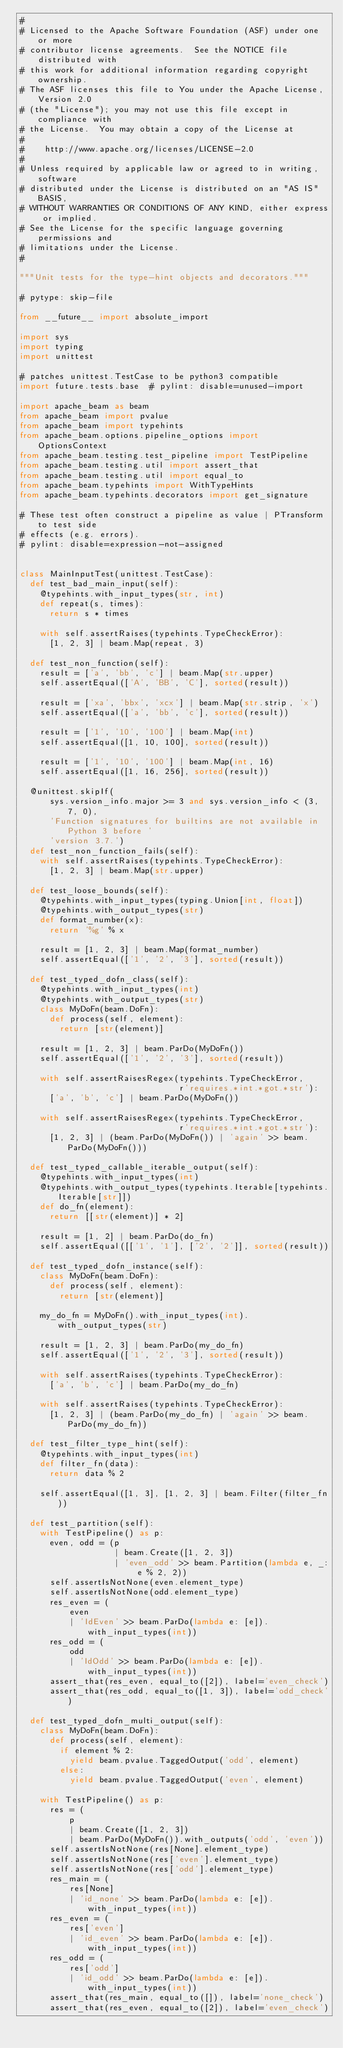Convert code to text. <code><loc_0><loc_0><loc_500><loc_500><_Python_>#
# Licensed to the Apache Software Foundation (ASF) under one or more
# contributor license agreements.  See the NOTICE file distributed with
# this work for additional information regarding copyright ownership.
# The ASF licenses this file to You under the Apache License, Version 2.0
# (the "License"); you may not use this file except in compliance with
# the License.  You may obtain a copy of the License at
#
#    http://www.apache.org/licenses/LICENSE-2.0
#
# Unless required by applicable law or agreed to in writing, software
# distributed under the License is distributed on an "AS IS" BASIS,
# WITHOUT WARRANTIES OR CONDITIONS OF ANY KIND, either express or implied.
# See the License for the specific language governing permissions and
# limitations under the License.
#

"""Unit tests for the type-hint objects and decorators."""

# pytype: skip-file

from __future__ import absolute_import

import sys
import typing
import unittest

# patches unittest.TestCase to be python3 compatible
import future.tests.base  # pylint: disable=unused-import

import apache_beam as beam
from apache_beam import pvalue
from apache_beam import typehints
from apache_beam.options.pipeline_options import OptionsContext
from apache_beam.testing.test_pipeline import TestPipeline
from apache_beam.testing.util import assert_that
from apache_beam.testing.util import equal_to
from apache_beam.typehints import WithTypeHints
from apache_beam.typehints.decorators import get_signature

# These test often construct a pipeline as value | PTransform to test side
# effects (e.g. errors).
# pylint: disable=expression-not-assigned


class MainInputTest(unittest.TestCase):
  def test_bad_main_input(self):
    @typehints.with_input_types(str, int)
    def repeat(s, times):
      return s * times

    with self.assertRaises(typehints.TypeCheckError):
      [1, 2, 3] | beam.Map(repeat, 3)

  def test_non_function(self):
    result = ['a', 'bb', 'c'] | beam.Map(str.upper)
    self.assertEqual(['A', 'BB', 'C'], sorted(result))

    result = ['xa', 'bbx', 'xcx'] | beam.Map(str.strip, 'x')
    self.assertEqual(['a', 'bb', 'c'], sorted(result))

    result = ['1', '10', '100'] | beam.Map(int)
    self.assertEqual([1, 10, 100], sorted(result))

    result = ['1', '10', '100'] | beam.Map(int, 16)
    self.assertEqual([1, 16, 256], sorted(result))

  @unittest.skipIf(
      sys.version_info.major >= 3 and sys.version_info < (3, 7, 0),
      'Function signatures for builtins are not available in Python 3 before '
      'version 3.7.')
  def test_non_function_fails(self):
    with self.assertRaises(typehints.TypeCheckError):
      [1, 2, 3] | beam.Map(str.upper)

  def test_loose_bounds(self):
    @typehints.with_input_types(typing.Union[int, float])
    @typehints.with_output_types(str)
    def format_number(x):
      return '%g' % x

    result = [1, 2, 3] | beam.Map(format_number)
    self.assertEqual(['1', '2', '3'], sorted(result))

  def test_typed_dofn_class(self):
    @typehints.with_input_types(int)
    @typehints.with_output_types(str)
    class MyDoFn(beam.DoFn):
      def process(self, element):
        return [str(element)]

    result = [1, 2, 3] | beam.ParDo(MyDoFn())
    self.assertEqual(['1', '2', '3'], sorted(result))

    with self.assertRaisesRegex(typehints.TypeCheckError,
                                r'requires.*int.*got.*str'):
      ['a', 'b', 'c'] | beam.ParDo(MyDoFn())

    with self.assertRaisesRegex(typehints.TypeCheckError,
                                r'requires.*int.*got.*str'):
      [1, 2, 3] | (beam.ParDo(MyDoFn()) | 'again' >> beam.ParDo(MyDoFn()))

  def test_typed_callable_iterable_output(self):
    @typehints.with_input_types(int)
    @typehints.with_output_types(typehints.Iterable[typehints.Iterable[str]])
    def do_fn(element):
      return [[str(element)] * 2]

    result = [1, 2] | beam.ParDo(do_fn)
    self.assertEqual([['1', '1'], ['2', '2']], sorted(result))

  def test_typed_dofn_instance(self):
    class MyDoFn(beam.DoFn):
      def process(self, element):
        return [str(element)]

    my_do_fn = MyDoFn().with_input_types(int).with_output_types(str)

    result = [1, 2, 3] | beam.ParDo(my_do_fn)
    self.assertEqual(['1', '2', '3'], sorted(result))

    with self.assertRaises(typehints.TypeCheckError):
      ['a', 'b', 'c'] | beam.ParDo(my_do_fn)

    with self.assertRaises(typehints.TypeCheckError):
      [1, 2, 3] | (beam.ParDo(my_do_fn) | 'again' >> beam.ParDo(my_do_fn))

  def test_filter_type_hint(self):
    @typehints.with_input_types(int)
    def filter_fn(data):
      return data % 2

    self.assertEqual([1, 3], [1, 2, 3] | beam.Filter(filter_fn))

  def test_partition(self):
    with TestPipeline() as p:
      even, odd = (p
                   | beam.Create([1, 2, 3])
                   | 'even_odd' >> beam.Partition(lambda e, _: e % 2, 2))
      self.assertIsNotNone(even.element_type)
      self.assertIsNotNone(odd.element_type)
      res_even = (
          even
          | 'IdEven' >> beam.ParDo(lambda e: [e]).with_input_types(int))
      res_odd = (
          odd
          | 'IdOdd' >> beam.ParDo(lambda e: [e]).with_input_types(int))
      assert_that(res_even, equal_to([2]), label='even_check')
      assert_that(res_odd, equal_to([1, 3]), label='odd_check')

  def test_typed_dofn_multi_output(self):
    class MyDoFn(beam.DoFn):
      def process(self, element):
        if element % 2:
          yield beam.pvalue.TaggedOutput('odd', element)
        else:
          yield beam.pvalue.TaggedOutput('even', element)

    with TestPipeline() as p:
      res = (
          p
          | beam.Create([1, 2, 3])
          | beam.ParDo(MyDoFn()).with_outputs('odd', 'even'))
      self.assertIsNotNone(res[None].element_type)
      self.assertIsNotNone(res['even'].element_type)
      self.assertIsNotNone(res['odd'].element_type)
      res_main = (
          res[None]
          | 'id_none' >> beam.ParDo(lambda e: [e]).with_input_types(int))
      res_even = (
          res['even']
          | 'id_even' >> beam.ParDo(lambda e: [e]).with_input_types(int))
      res_odd = (
          res['odd']
          | 'id_odd' >> beam.ParDo(lambda e: [e]).with_input_types(int))
      assert_that(res_main, equal_to([]), label='none_check')
      assert_that(res_even, equal_to([2]), label='even_check')</code> 